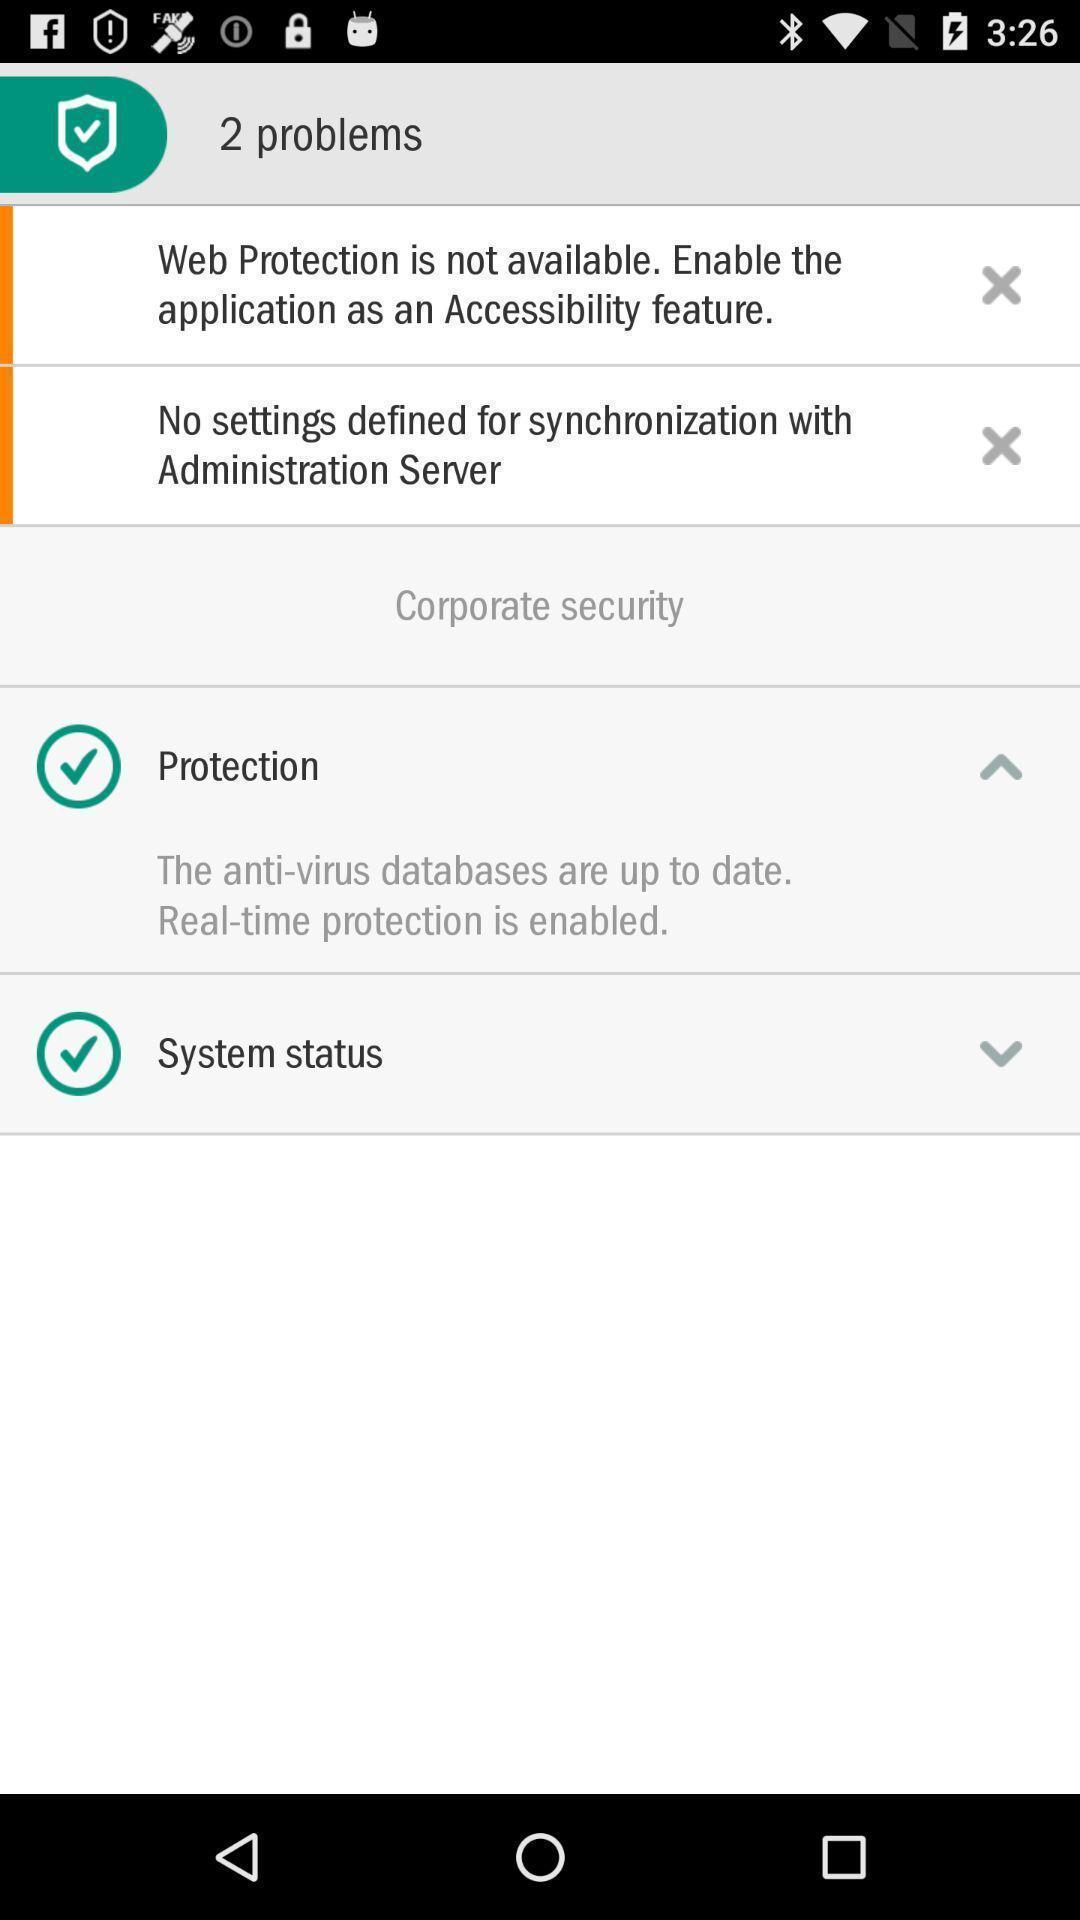Summarize the information in this screenshot. Two problems are showing in the security app. 